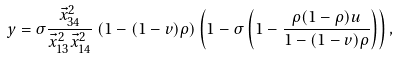Convert formula to latex. <formula><loc_0><loc_0><loc_500><loc_500>y = \sigma \frac { \vec { x } ^ { 2 } _ { 3 4 } } { \vec { x } ^ { 2 } _ { 1 3 } \vec { x } ^ { 2 } _ { 1 4 } } \left ( 1 - ( 1 - v ) \rho \right ) \left ( 1 - \sigma \left ( 1 - \frac { \rho ( 1 - \rho ) u } { 1 - ( 1 - v ) \rho } \right ) \right ) ,</formula> 